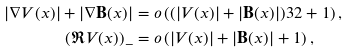Convert formula to latex. <formula><loc_0><loc_0><loc_500><loc_500>| \nabla V ( x ) | + | \nabla \mathbf B ( x ) | & = o \left ( ( | V ( x ) | + | \mathbf B ( x ) | ) ^ { } { 3 } 2 + 1 \right ) , \\ ( \Re V ( x ) ) _ { - } & = o \left ( | V ( x ) | + | \mathbf B ( x ) | + 1 \right ) ,</formula> 